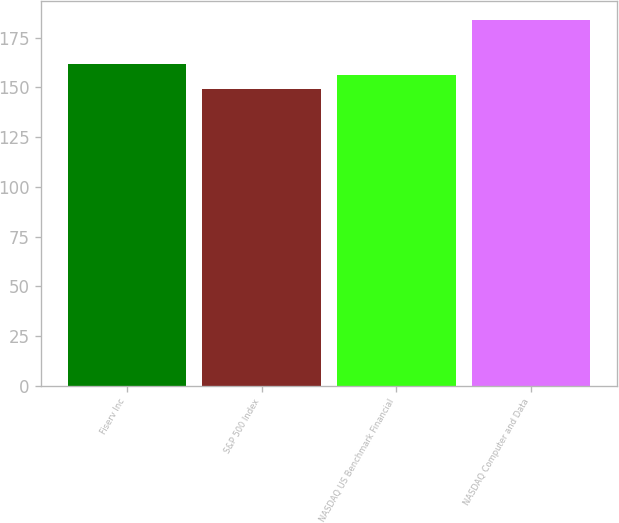Convert chart to OTSL. <chart><loc_0><loc_0><loc_500><loc_500><bar_chart><fcel>Fiserv Inc<fcel>S&P 500 Index<fcel>NASDAQ US Benchmark Financial<fcel>NASDAQ Computer and Data<nl><fcel>162<fcel>149<fcel>156<fcel>184<nl></chart> 